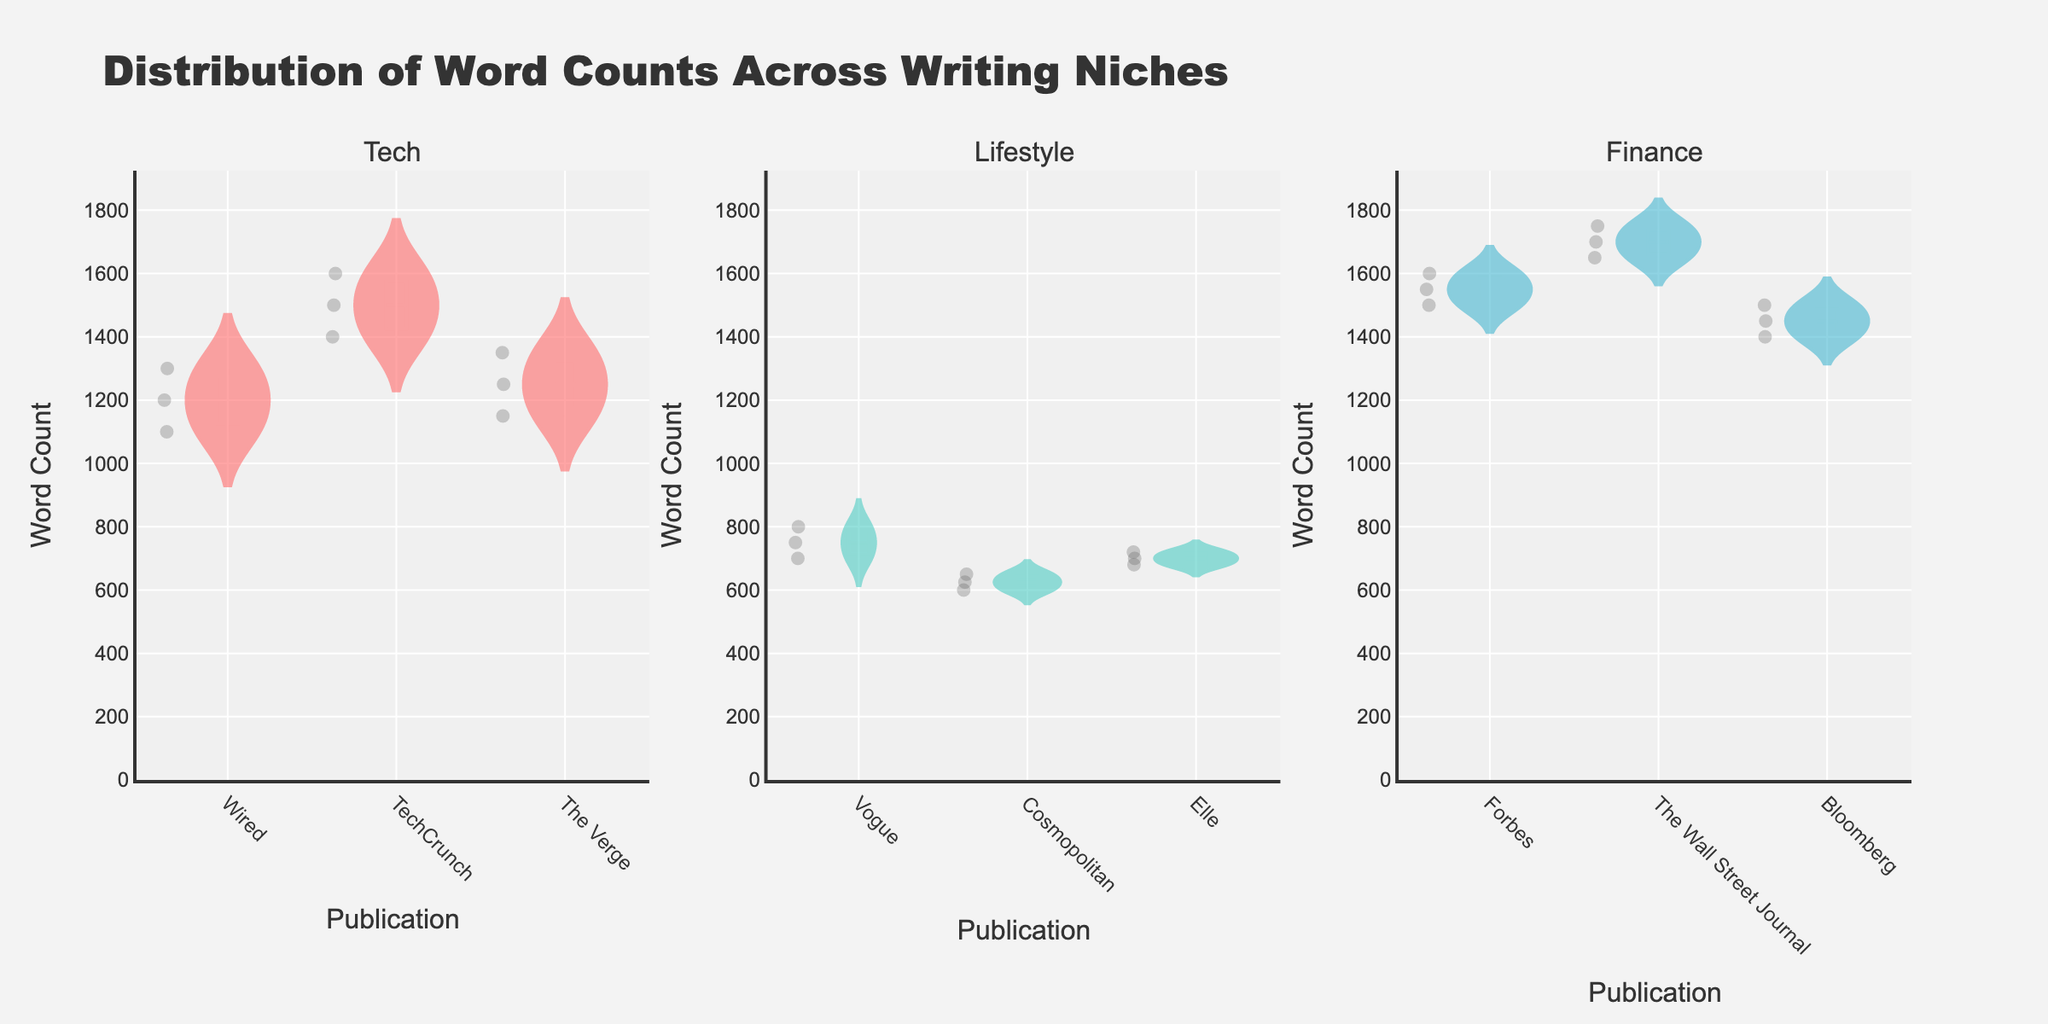What is the title of the figure? The title is displayed at the top of the figure.
Answer: Distribution of Word Counts Across Writing Niches Which niche has the widest range of word counts? Compare the spread of the violins across each subplot. The Finance niche has the widest spread from around 1400 to 1750.
Answer: Finance What is the approximate median word count for articles in TechCrunch? Look at the horizontal line within the TechCrunch violin (Tech subplot) representing the median.
Answer: 1500 Which publication in the Lifestyle niche has the lowest median word count? Compare the median lines (horizontal lines in the middle) of each Lifestyle publication (Vogue, Cosmopolitan, Elle). Cosmopolitan has the lowest median line.
Answer: Cosmopolitan How do the word count distributions of Wired and The Verge compare? Examine the Tech subplot with the violins for Wired and The Verge. The word counts for Wired are slightly higher overall compared to The Verge.
Answer: Wired's word counts are generally higher than The Verge's Between Lifestyle and Finance niches, which has more consistent word counts across publications? Consistency is indicated by narrower violins (less spread). The Lifestyle niche violins are narrower compared to the Finance niche.
Answer: Lifestyle What is the mean word count for articles in Vogue? The mean is represented by the dashed line within the Vogue violin in the Lifestyle subplot.
Answer: Approximately 750 Are there any outliers in the Finance niche? If so, for which publication? Check for data points that lie outside the main distribution of the violin plots in the Finance subplot. There are outliers in The Wall Street Journal.
Answer: Yes, The Wall Street Journal Which niche has the highest median word count? Compare the medians (horizontal lines) across the Tech, Lifestyle, and Finance subplots. Finance has the highest median word count.
Answer: Finance How does the word count of The Verge compare to TechCrunch? Look at both violins in the Tech subplot. The Verge's word counts are lower and less spread out than TechCrunch's.
Answer: The Verge's word counts are lower and less spread than TechCrunch's 